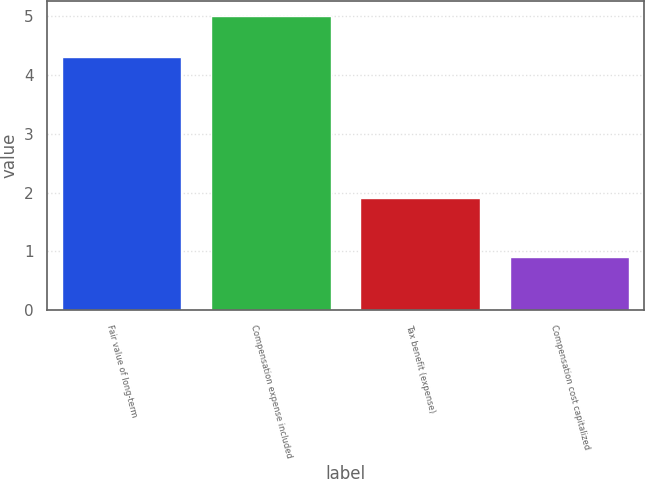Convert chart to OTSL. <chart><loc_0><loc_0><loc_500><loc_500><bar_chart><fcel>Fair value of long-term<fcel>Compensation expense included<fcel>Tax benefit (expense)<fcel>Compensation cost capitalized<nl><fcel>4.3<fcel>5<fcel>1.9<fcel>0.9<nl></chart> 